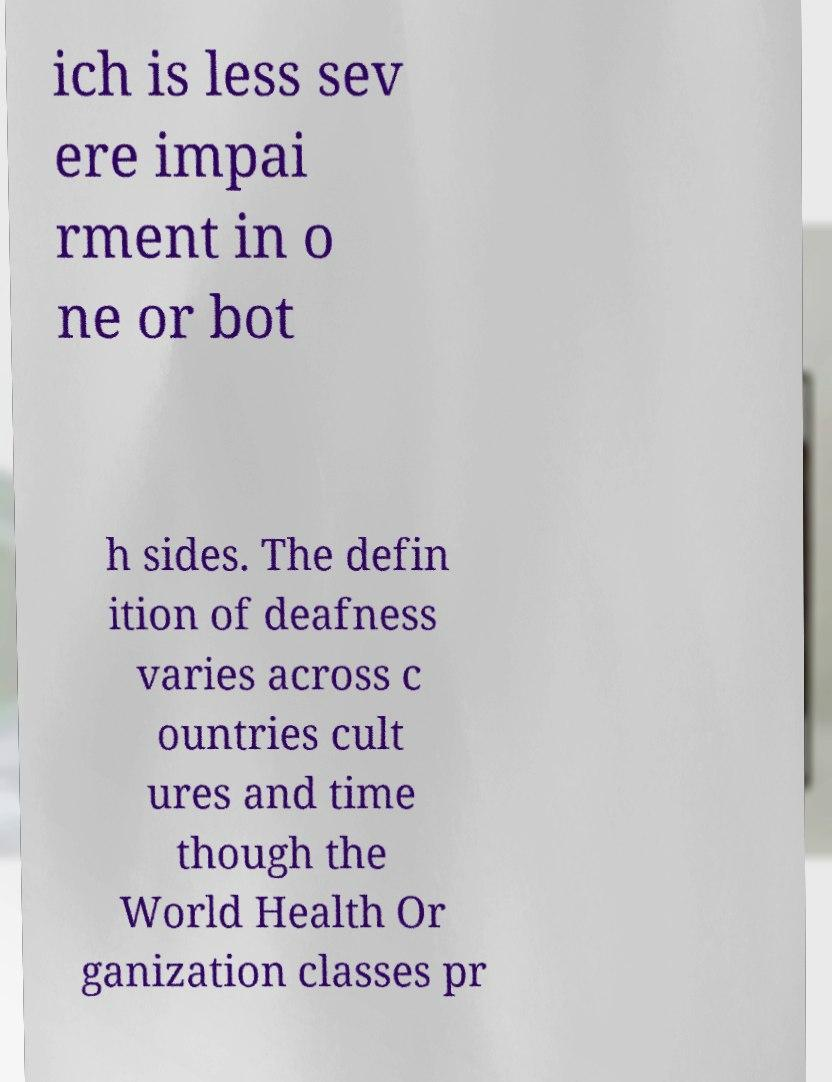Please read and relay the text visible in this image. What does it say? ich is less sev ere impai rment in o ne or bot h sides. The defin ition of deafness varies across c ountries cult ures and time though the World Health Or ganization classes pr 